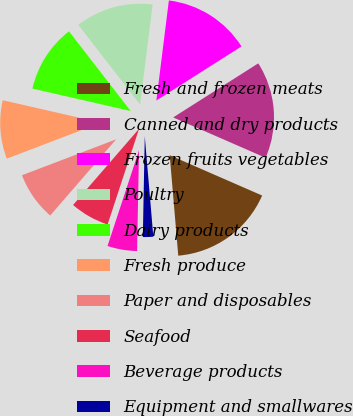Convert chart. <chart><loc_0><loc_0><loc_500><loc_500><pie_chart><fcel>Fresh and frozen meats<fcel>Canned and dry products<fcel>Frozen fruits vegetables<fcel>Poultry<fcel>Dairy products<fcel>Fresh produce<fcel>Paper and disposables<fcel>Seafood<fcel>Beverage products<fcel>Equipment and smallwares<nl><fcel>17.1%<fcel>15.56%<fcel>14.01%<fcel>12.47%<fcel>10.93%<fcel>9.38%<fcel>7.84%<fcel>6.3%<fcel>4.75%<fcel>1.66%<nl></chart> 